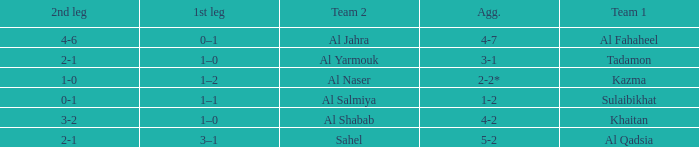What is the 1st leg of the match with a 2nd leg of 3-2? 1–0. Can you parse all the data within this table? {'header': ['2nd leg', '1st leg', 'Team 2', 'Agg.', 'Team 1'], 'rows': [['4-6', '0–1', 'Al Jahra', '4-7', 'Al Fahaheel'], ['2-1', '1–0', 'Al Yarmouk', '3-1', 'Tadamon'], ['1-0', '1–2', 'Al Naser', '2-2*', 'Kazma'], ['0-1', '1–1', 'Al Salmiya', '1-2', 'Sulaibikhat'], ['3-2', '1–0', 'Al Shabab', '4-2', 'Khaitan'], ['2-1', '3–1', 'Sahel', '5-2', 'Al Qadsia']]} 